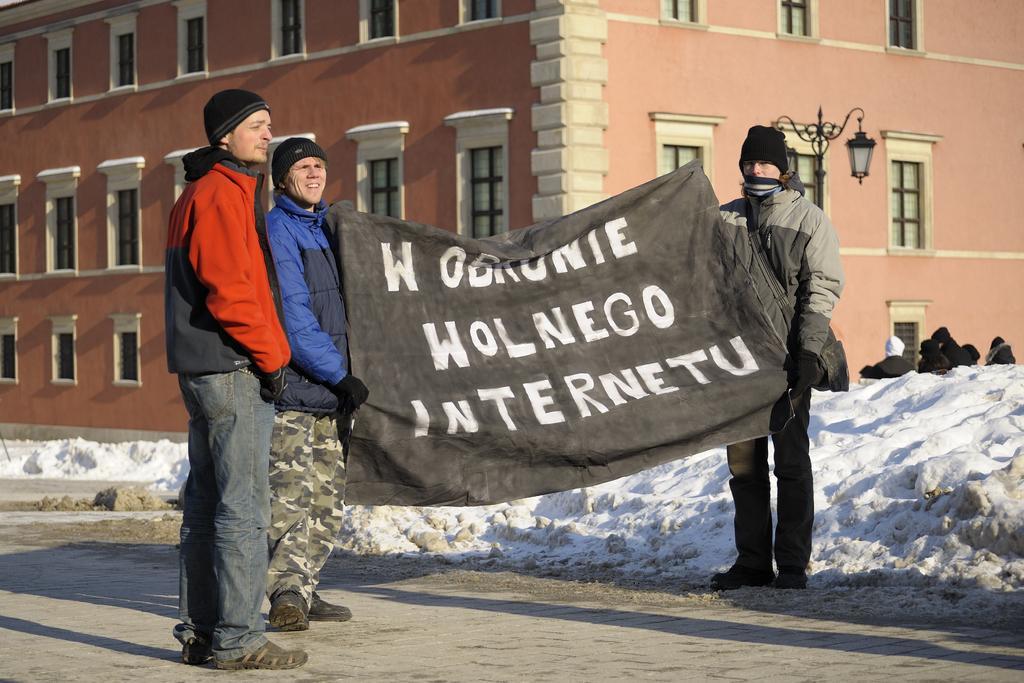Please provide a concise description of this image. As we can see in the image there are buildings, street lamp, three people holding banner and there is snow. 